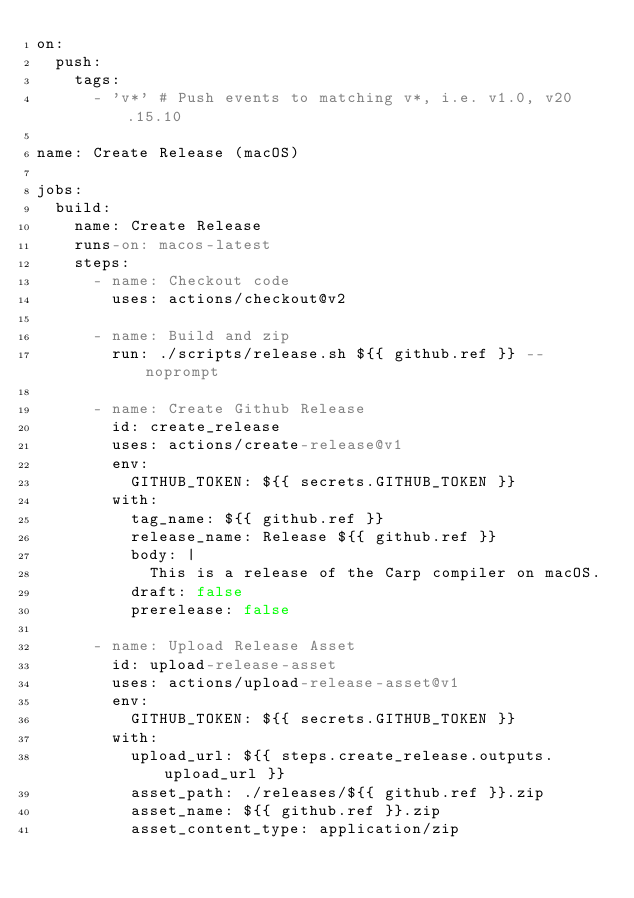<code> <loc_0><loc_0><loc_500><loc_500><_YAML_>on:
  push:
    tags:
      - 'v*' # Push events to matching v*, i.e. v1.0, v20.15.10

name: Create Release (macOS)

jobs:
  build:
    name: Create Release
    runs-on: macos-latest
    steps:
      - name: Checkout code
        uses: actions/checkout@v2

      - name: Build and zip
        run: ./scripts/release.sh ${{ github.ref }} --noprompt

      - name: Create Github Release
        id: create_release
        uses: actions/create-release@v1
        env:
          GITHUB_TOKEN: ${{ secrets.GITHUB_TOKEN }}
        with:
          tag_name: ${{ github.ref }}
          release_name: Release ${{ github.ref }}
          body: |
            This is a release of the Carp compiler on macOS.
          draft: false
          prerelease: false

      - name: Upload Release Asset
        id: upload-release-asset
        uses: actions/upload-release-asset@v1
        env:
          GITHUB_TOKEN: ${{ secrets.GITHUB_TOKEN }}
        with:
          upload_url: ${{ steps.create_release.outputs.upload_url }}
          asset_path: ./releases/${{ github.ref }}.zip
          asset_name: ${{ github.ref }}.zip
          asset_content_type: application/zip
</code> 